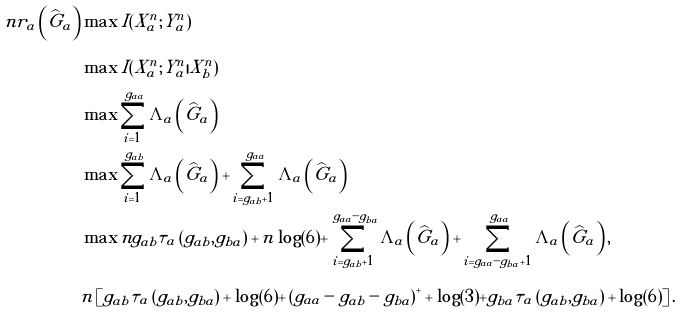Convert formula to latex. <formula><loc_0><loc_0><loc_500><loc_500>n r _ { a } \left ( \widehat { G } _ { a } \right ) & \max I ( X _ { a } ^ { n } ; Y _ { a } ^ { n } ) \\ & \max I ( X _ { a } ^ { n } ; Y _ { a } ^ { n } | X _ { b } ^ { n } ) \\ & \max \sum _ { i = 1 } ^ { g _ { a a } } \Lambda _ { a } \left ( \widehat { G } _ { a } \right ) \\ & \max \sum _ { i = 1 } ^ { g _ { a b } } \Lambda _ { a } \left ( \widehat { G } _ { a } \right ) + \sum _ { i = g _ { a b } + 1 } ^ { g _ { a a } } \Lambda _ { a } \left ( \widehat { G } _ { a } \right ) \\ & \max n g _ { a b } \tau _ { a } \left ( g _ { a b } , g _ { b a } \right ) + n \log ( 6 ) + \sum _ { i = g _ { a b } + 1 } ^ { g _ { a a } - g _ { b a } } \Lambda _ { a } \left ( \widehat { G } _ { a } \right ) + \sum _ { i = g _ { a a } - g _ { b a } + 1 } ^ { g _ { a a } } \Lambda _ { a } \left ( \widehat { G } _ { a } \right ) , \\ & n \left [ g _ { a b } \tau _ { a } \left ( g _ { a b } , g _ { b a } \right ) + \log ( 6 ) + \left ( g _ { a a } - g _ { a b } - g _ { b a } \right ) ^ { + } + \log ( 3 ) + g _ { b a } \tau _ { a } \left ( g _ { a b } , g _ { b a } \right ) + \log ( 6 ) \right ] .</formula> 